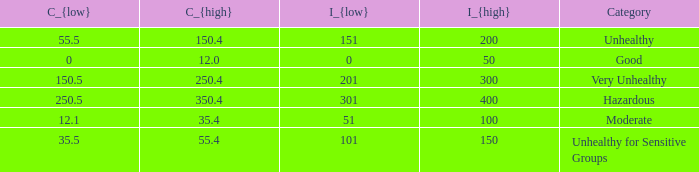How many different C_{high} values are there for the good category? 1.0. 